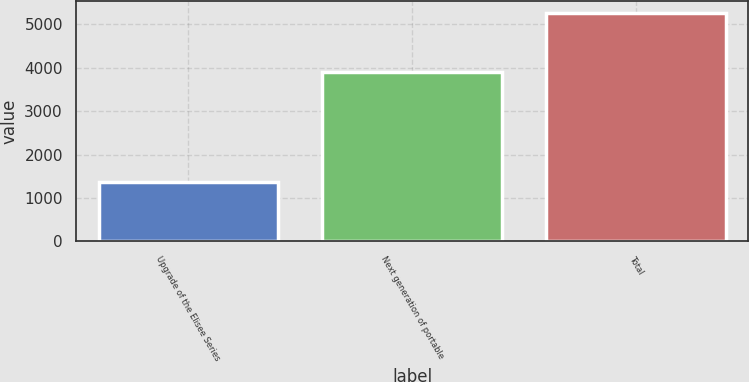Convert chart to OTSL. <chart><loc_0><loc_0><loc_500><loc_500><bar_chart><fcel>Upgrade of the Elisee Series<fcel>Next generation of portable<fcel>Total<nl><fcel>1379<fcel>3889<fcel>5268<nl></chart> 